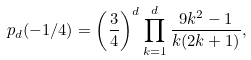Convert formula to latex. <formula><loc_0><loc_0><loc_500><loc_500>p _ { d } ( - 1 / 4 ) = \left ( \frac { 3 } { 4 } \right ) ^ { d } \prod _ { k = 1 } ^ { d } \frac { 9 k ^ { 2 } - 1 } { k ( 2 k + 1 ) } ,</formula> 